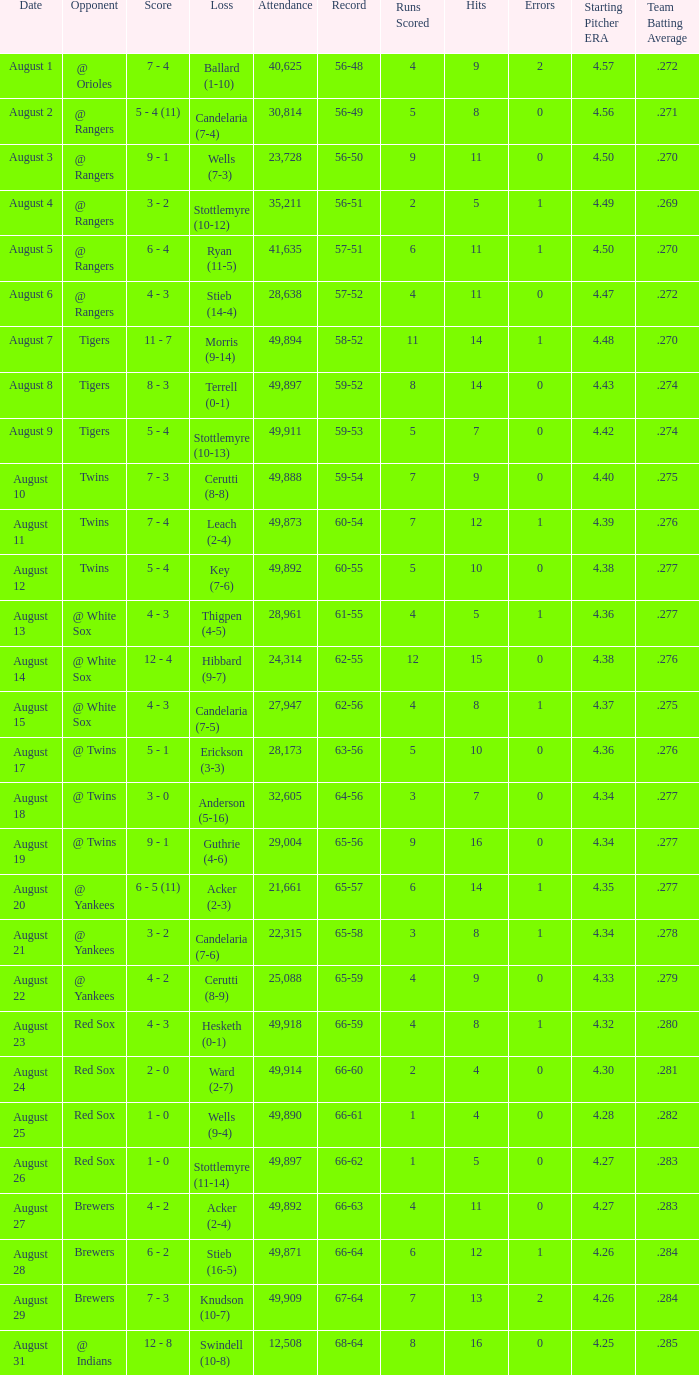What was the record of the game that had a loss of Stottlemyre (10-12)? 56-51. 